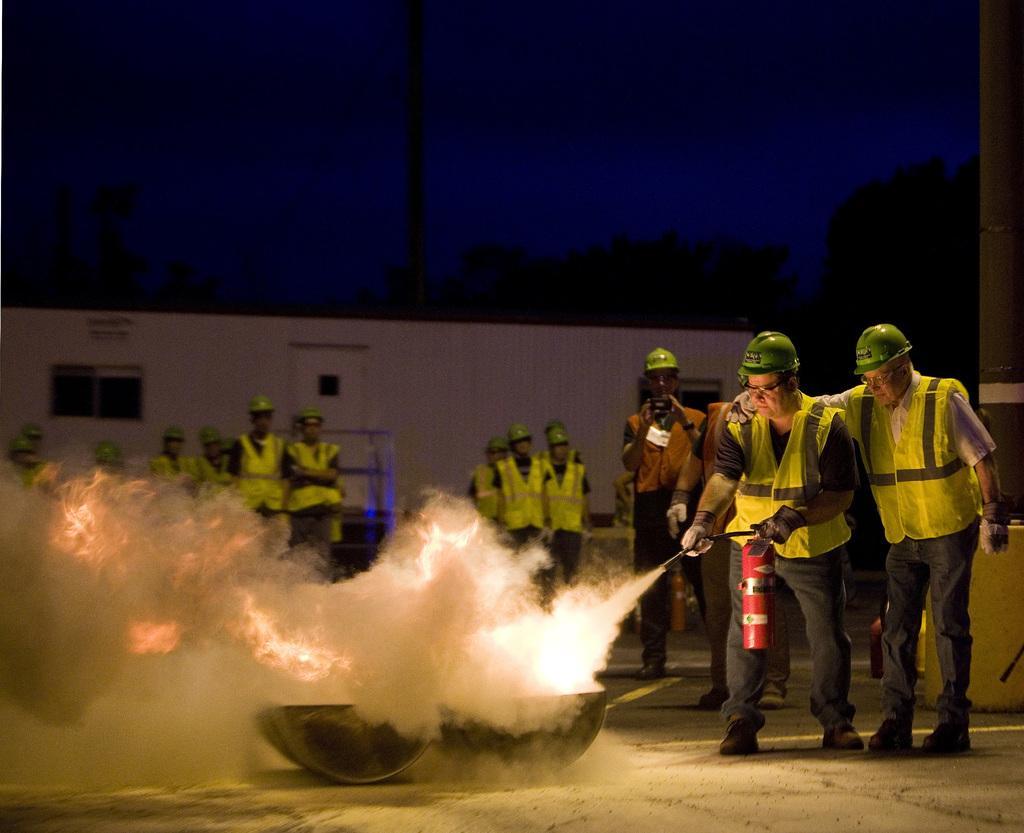Please provide a concise description of this image. In this image I can see few people with aprons and helmets. I can see one person is holding the fire extinguisher and there is a smoke in-front of the people. In the background I can see the shed, many trees and the sky. 